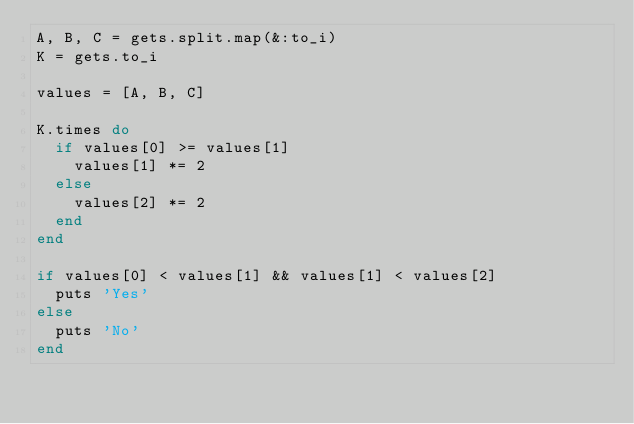Convert code to text. <code><loc_0><loc_0><loc_500><loc_500><_Ruby_>A, B, C = gets.split.map(&:to_i)
K = gets.to_i

values = [A, B, C]

K.times do
  if values[0] >= values[1]
    values[1] *= 2
  else
    values[2] *= 2
  end
end

if values[0] < values[1] && values[1] < values[2]
  puts 'Yes'
else
  puts 'No'
end
</code> 